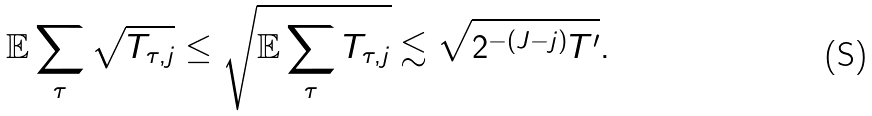Convert formula to latex. <formula><loc_0><loc_0><loc_500><loc_500>\mathbb { E } \sum _ { \tau } \sqrt { T _ { \tau , j } } \leq \sqrt { \mathbb { E } \sum _ { \tau } T _ { \tau , j } } \lesssim \sqrt { 2 ^ { - ( J - j ) } { T ^ { \prime } } } .</formula> 